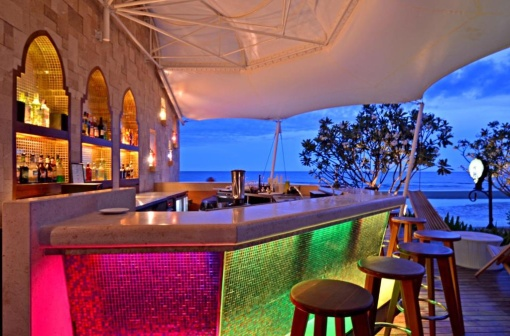Imagine a story that could take place in this setting. As the sun began to set, painting the sky in hues of pink and orange, a lonely traveler named Alex walked into the bar. The soft glow from the colorful lights and the gentle sea breeze created a perfect soothing ambiance. Alex, weary from days of wandering, took a seat at one of the unoccupied bar stools, letting the view of the ocean wash away the exhaustion. The bartender, a friendly local named Maria, approached with a warm smile and recommended a unique drink, the Sunset Paradise, infused with local tropical fruits. As Alex sipped on the delightful beverage, Maria shared tales of the island's history and legends, including the story of an ancient treasure said to be hidden somewhere along the vast coastline. Intrigued and revitalized by the conversation and the serene surroundings, Alex felt a spark of excitement. Perhaps this unexpected detour to the beachside bar was just the beginning of a new adventure, one filled with discovery, friendship, and the magic of the island. What kind of events might this bar host? This picturesque beachside bar could host a variety of events, each tailored to leverage its serene and scenic location. From intimate sunset weddings where the couple exchanges vows against the backdrop of the ocean, to lively beach parties featuring vibrant music, dancing, and colorful cocktails, the bar's versatile ambiance can cater to many themes. It could also host themed parties, such as tropical luau nights complete with traditional dances and attire, or artistic gatherings showcasing local musicians and artists. Furthermore, the bar could serve as a perfect spot for yoga retreats and wellness workshops, offering a peaceful haven for participants to rejuvenate amidst nature's beauty. Regular happy hours with special drink menus and occasional beach bonfires could keep locals and tourists entertained, making the bar a central hub of social activity on the coast. Can you describe a magical night that might take place here? On a magical night, the beachside bar transforms under the glow of a full moon, casting a silvery light over the entire scene. Lanterns hung around the canopy provide a warm, ethereal glow, mingling with the soft pink and green lights from the bar. As the gentle sound of live acoustic music fills the air, a small crowd gathers, their laughter and chatter blending harmoniously with the sound of waves crashing in the background. Fireflies dance around, adding a touch of enchantment to the atmosphere. Couples sway slowly under the stars, their faces alight with happiness and contentment.

In one corner, a fortune teller with a mystical aura offers readings, her cards reflecting the moonlight and promising glimpses into the future. The bartender, skilled in the art of mixology, prepares magical concoctions, using ingredients that glimmer and change colors, leaving patrons in awe of the spectacle.

As the night progresses, a sudden shooting star streaks across the sky, prompting gasps and wishes from everyone present. The unity of nature, music, and ambiance creates an unforgettable night, where every moment feels like a page out of a fairy tale, leaving an indelible impression on all who experienced its magic. 